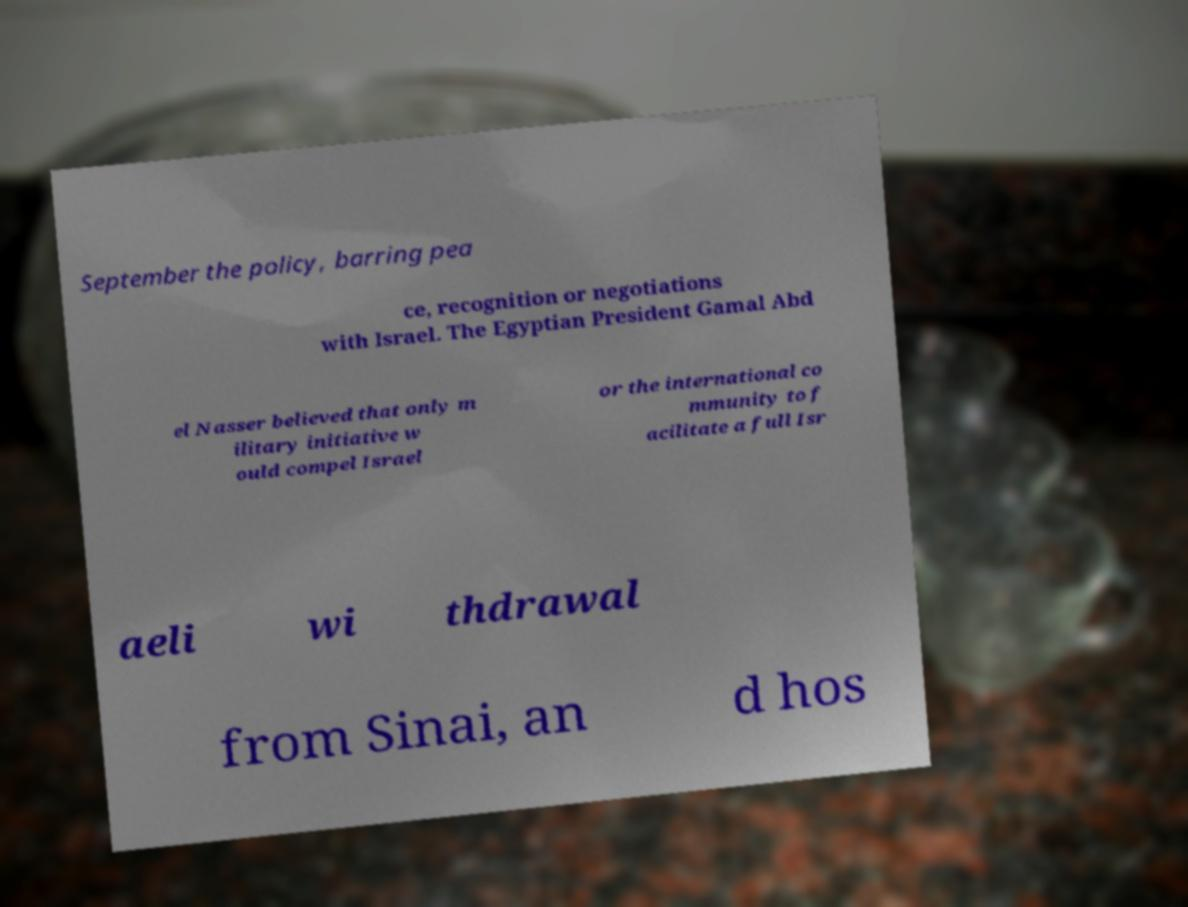Could you extract and type out the text from this image? September the policy, barring pea ce, recognition or negotiations with Israel. The Egyptian President Gamal Abd el Nasser believed that only m ilitary initiative w ould compel Israel or the international co mmunity to f acilitate a full Isr aeli wi thdrawal from Sinai, an d hos 